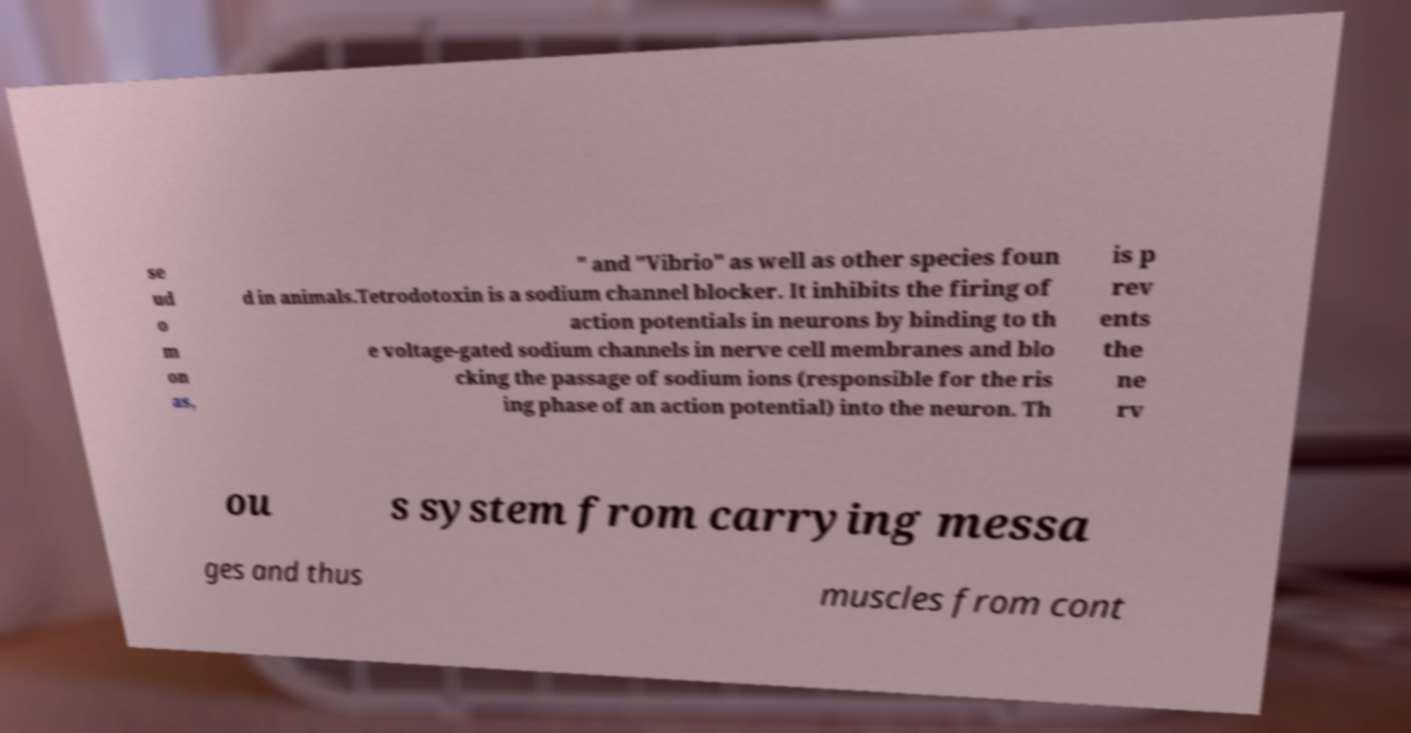Can you read and provide the text displayed in the image?This photo seems to have some interesting text. Can you extract and type it out for me? se ud o m on as, " and "Vibrio" as well as other species foun d in animals.Tetrodotoxin is a sodium channel blocker. It inhibits the firing of action potentials in neurons by binding to th e voltage-gated sodium channels in nerve cell membranes and blo cking the passage of sodium ions (responsible for the ris ing phase of an action potential) into the neuron. Th is p rev ents the ne rv ou s system from carrying messa ges and thus muscles from cont 